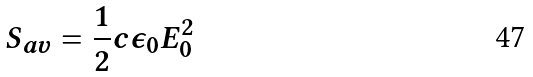Convert formula to latex. <formula><loc_0><loc_0><loc_500><loc_500>S _ { a v } = \frac { 1 } { 2 } c \epsilon _ { 0 } E _ { 0 } ^ { 2 }</formula> 